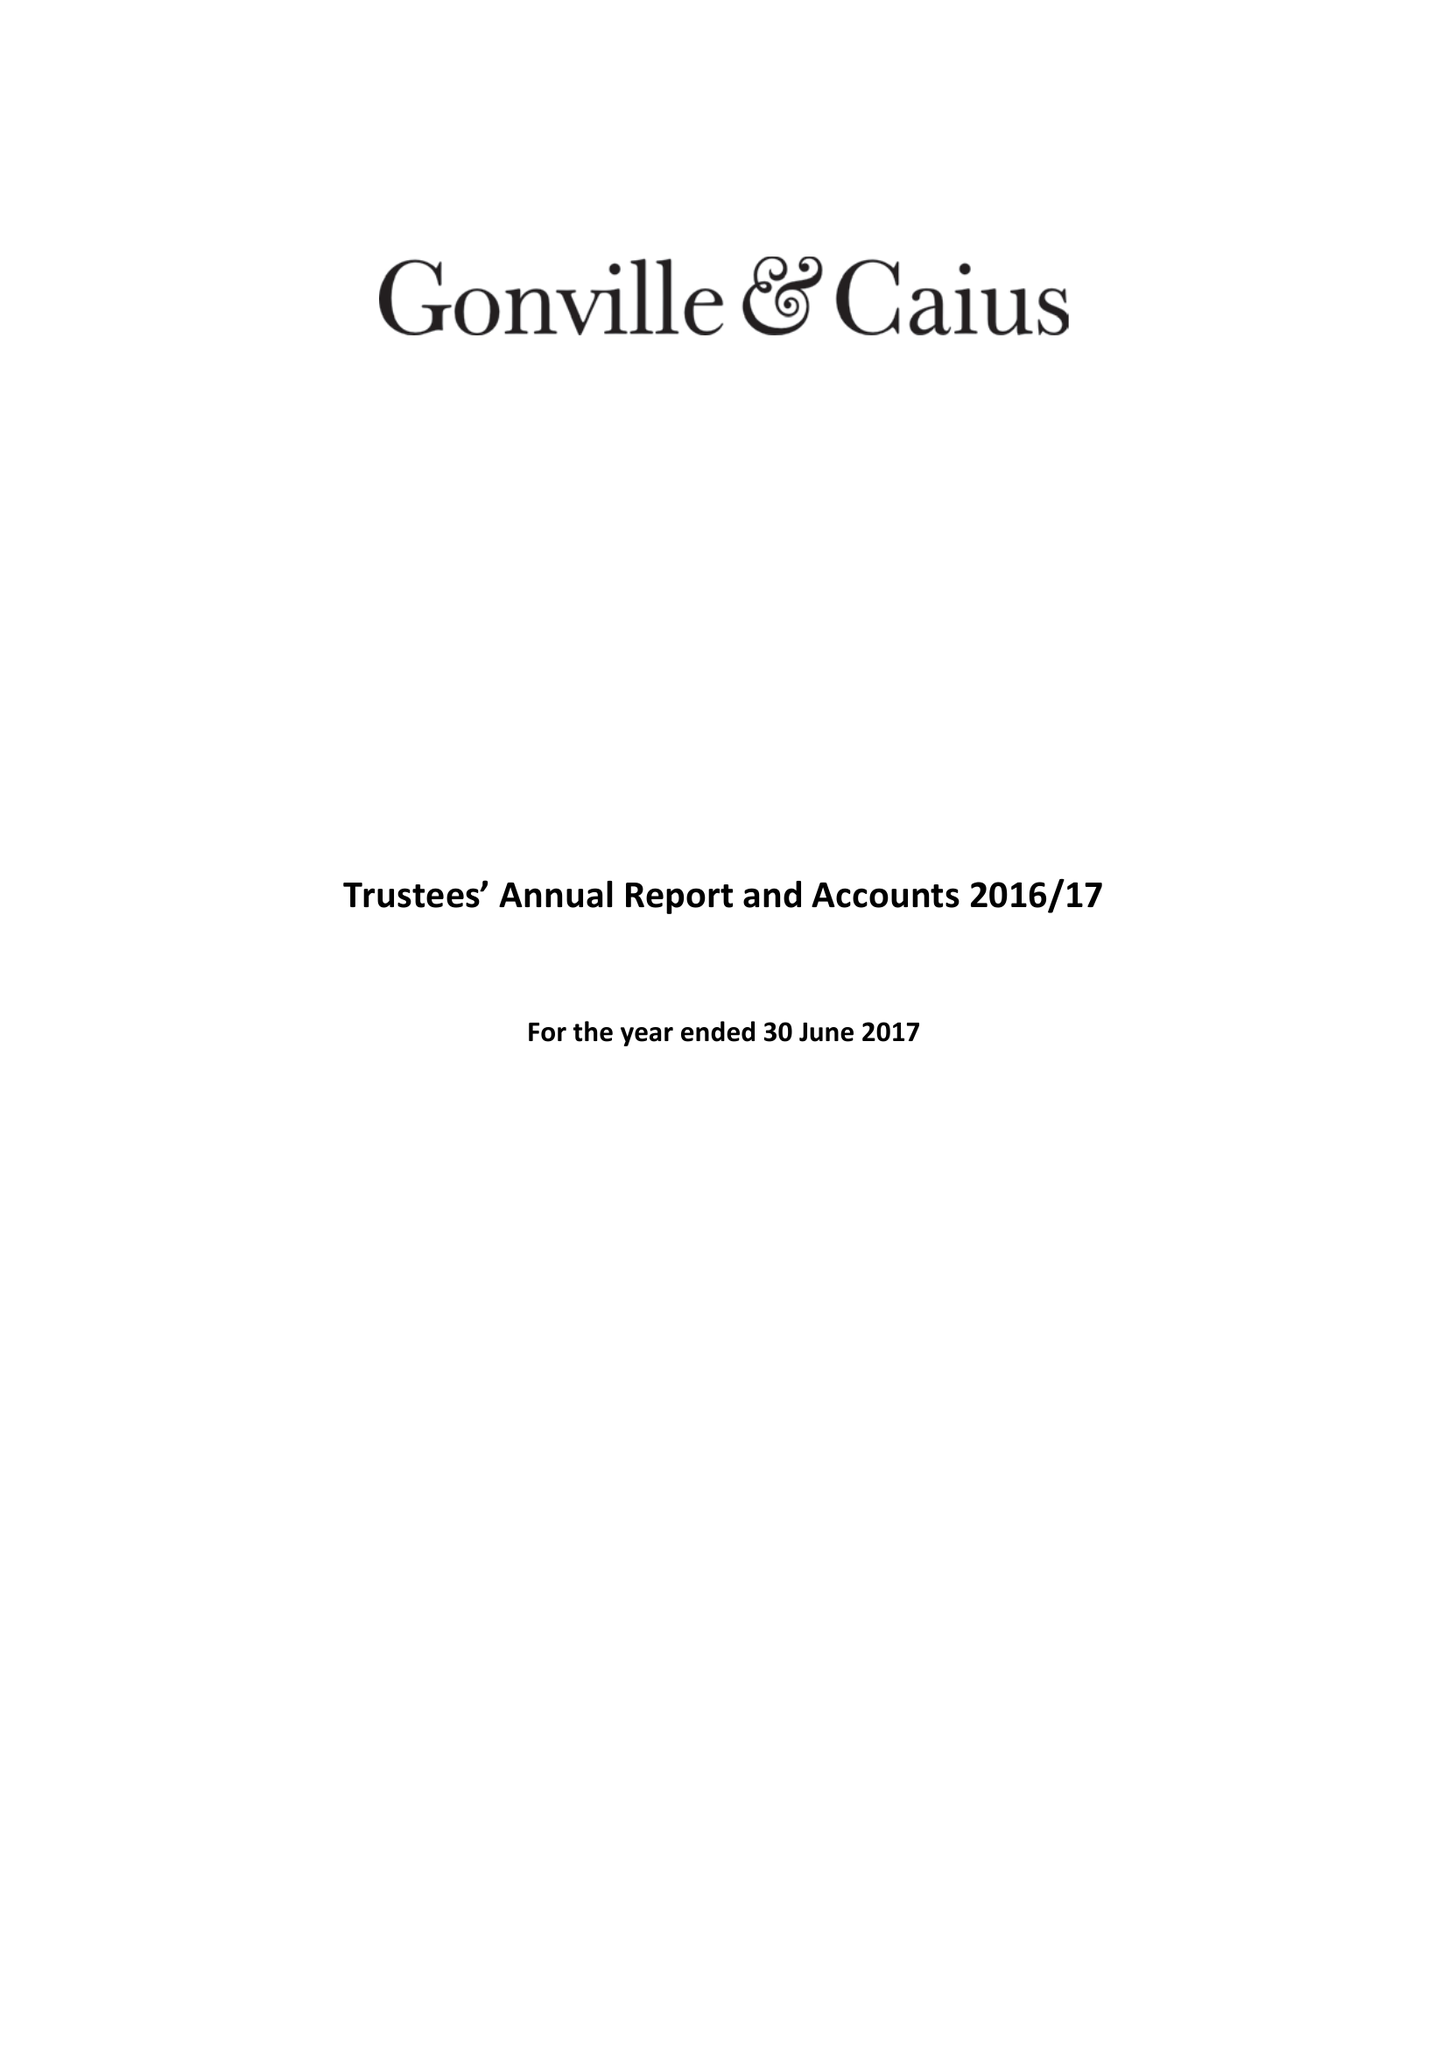What is the value for the charity_number?
Answer the question using a single word or phrase. 1137536 